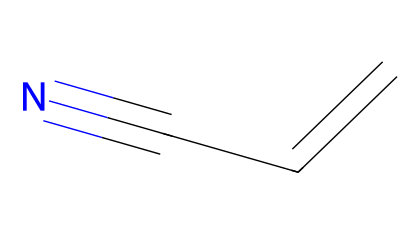What is the name of the chemical represented by the SMILES? The SMILES notation 'C=CC#N' corresponds to acrylonitrile, which can be identified by its common name related to the presence of the nitrile functional group and its alkenyl structure.
Answer: acrylonitrile How many carbon atoms are in the chemical structure? The structure includes two carbon atoms from the 'C=CC' part and shows that they are linked together, plus a third carbon atom connected to the nitrile group, leading to a total of three carbon atoms in the molecule.
Answer: three What type of functional group is present in this chemical? The presence of the cyano group 'C#N' at the end indicates that this molecule contains a nitrile functional group, which is characteristic for acrylonitrile.
Answer: nitrile What is the degree of unsaturation in acrylonitrile? To determine the degree of unsaturation, we note the presence of the double bond 'C=C' and the triple bond 'C#N'. Each double bond contributes one degree and each triple bond contributes two degrees, leading to a total of three degrees of unsaturation.
Answer: three Does acrylonitrile have any aromatic character? Aromatic compounds typically display a cyclic structure and delocalized pi electrons, which acrylonitrile lacks as it is a linear molecule with a double bond and nitrile, so there is no aromaticity in this structure.
Answer: no What is the total number of hydrogen atoms in acrylonitrile? Analyzing the structure: with three carbon atoms, and accounting for a total of six possible single bond attachments, minus the two double bond connections (each removes one hydrogen and one connects to a C atom) and minus the bond with the nitrogen (which takes one hydrogen), results in a total of three hydrogen atoms.
Answer: three 